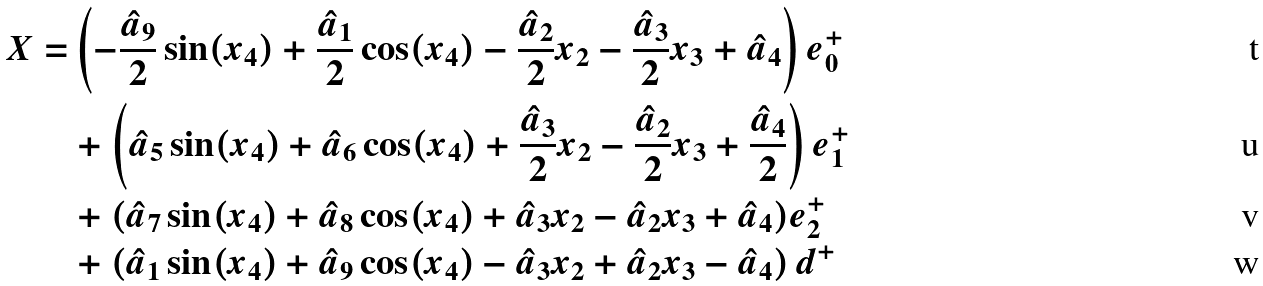<formula> <loc_0><loc_0><loc_500><loc_500>X = & \left ( - \frac { \hat { a } _ { 9 } } { 2 } \sin ( x _ { 4 } ) + \frac { \hat { a } _ { 1 } } { 2 } \cos ( x _ { 4 } ) - \frac { \hat { a } _ { 2 } } { 2 } x _ { 2 } - \frac { \hat { a } _ { 3 } } { 2 } x _ { 3 } + \hat { a } _ { 4 } \right ) e _ { 0 } ^ { + } \\ & + \left ( \hat { a } _ { 5 } \sin ( x _ { 4 } ) + \hat { a } _ { 6 } \cos ( x _ { 4 } ) + \frac { \hat { a } _ { 3 } } { 2 } x _ { 2 } - \frac { \hat { a } _ { 2 } } { 2 } x _ { 3 } + \frac { \hat { a } _ { 4 } } { 2 } \right ) e _ { 1 } ^ { + } \\ & + ( \hat { a } _ { 7 } \sin ( x _ { 4 } ) + \hat { a } _ { 8 } \cos ( x _ { 4 } ) + \hat { a } _ { 3 } x _ { 2 } - \hat { a } _ { 2 } x _ { 3 } + \hat { a } _ { 4 } ) e _ { 2 } ^ { + } \\ & + \left ( \hat { a } _ { 1 } \sin ( x _ { 4 } ) + \hat { a } _ { 9 } \cos ( x _ { 4 } ) - \hat { a } _ { 3 } x _ { 2 } + \hat { a } _ { 2 } x _ { 3 } - \hat { a } _ { 4 } \right ) d ^ { + }</formula> 